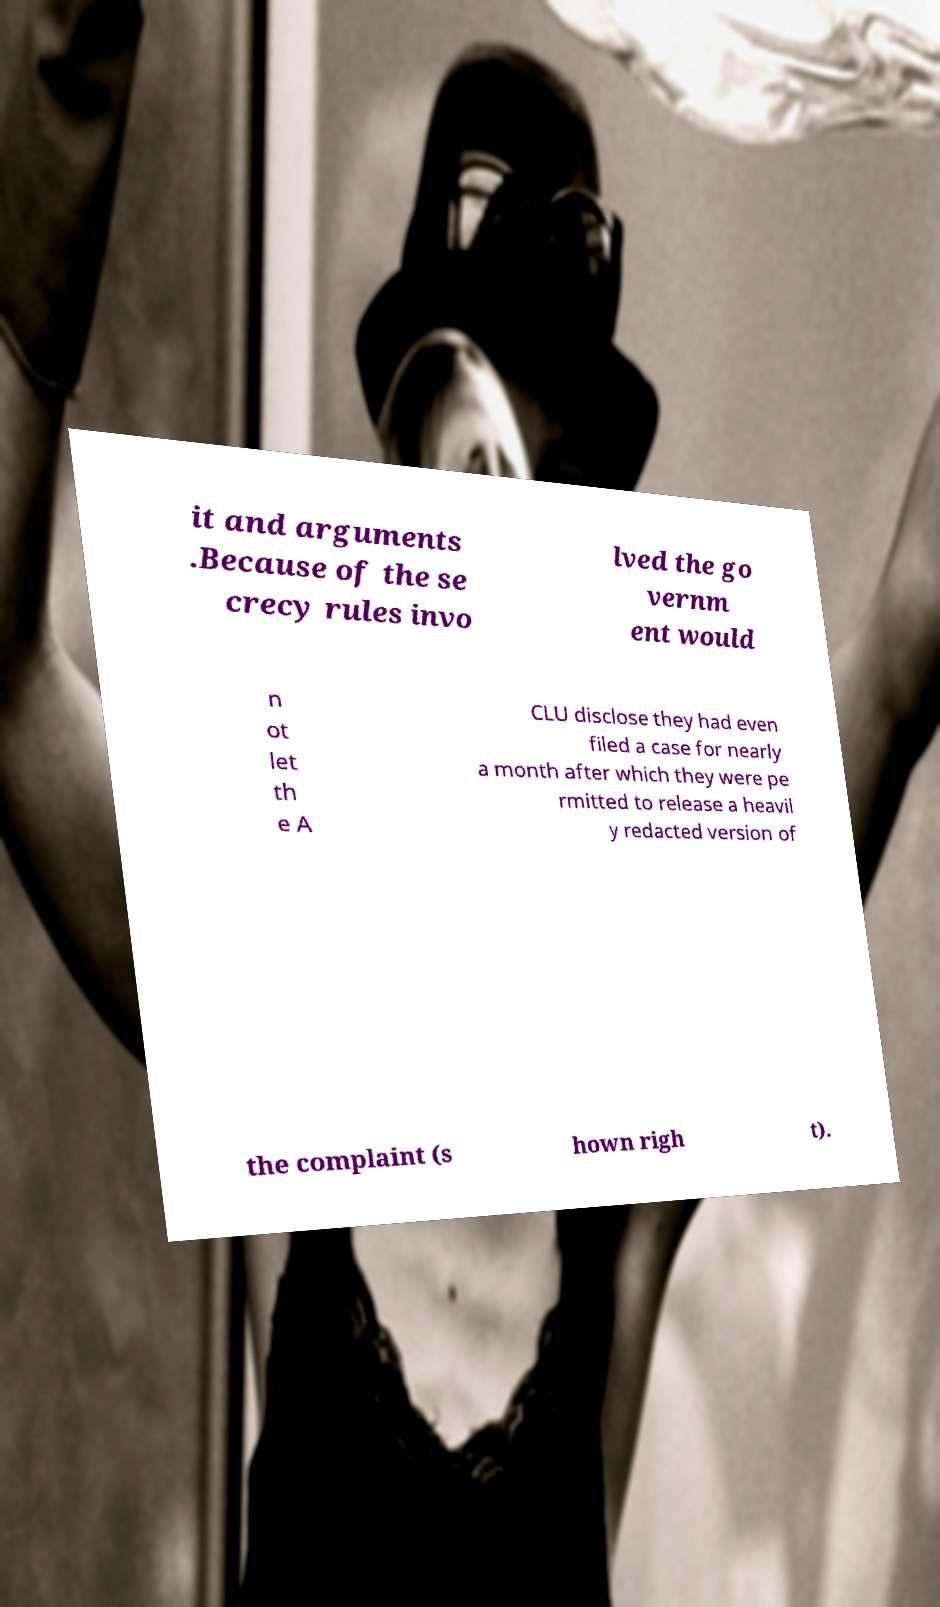For documentation purposes, I need the text within this image transcribed. Could you provide that? it and arguments .Because of the se crecy rules invo lved the go vernm ent would n ot let th e A CLU disclose they had even filed a case for nearly a month after which they were pe rmitted to release a heavil y redacted version of the complaint (s hown righ t). 